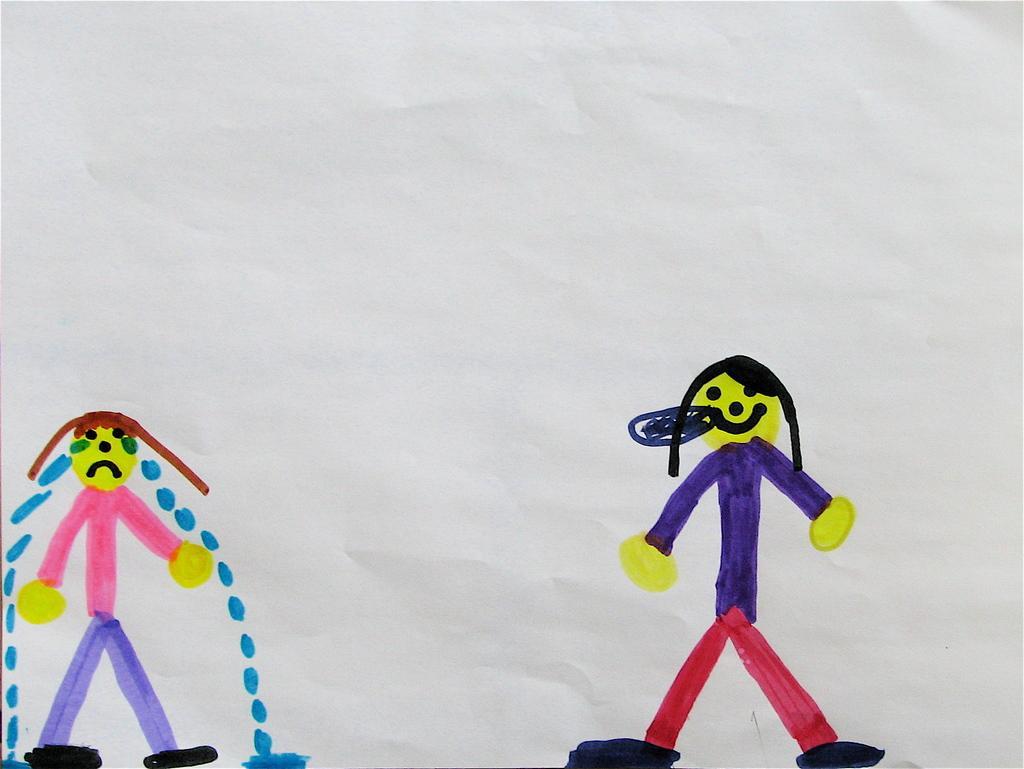In one or two sentences, can you explain what this image depicts? In this image I can see the cartoon paintings of persons on a white paper. 